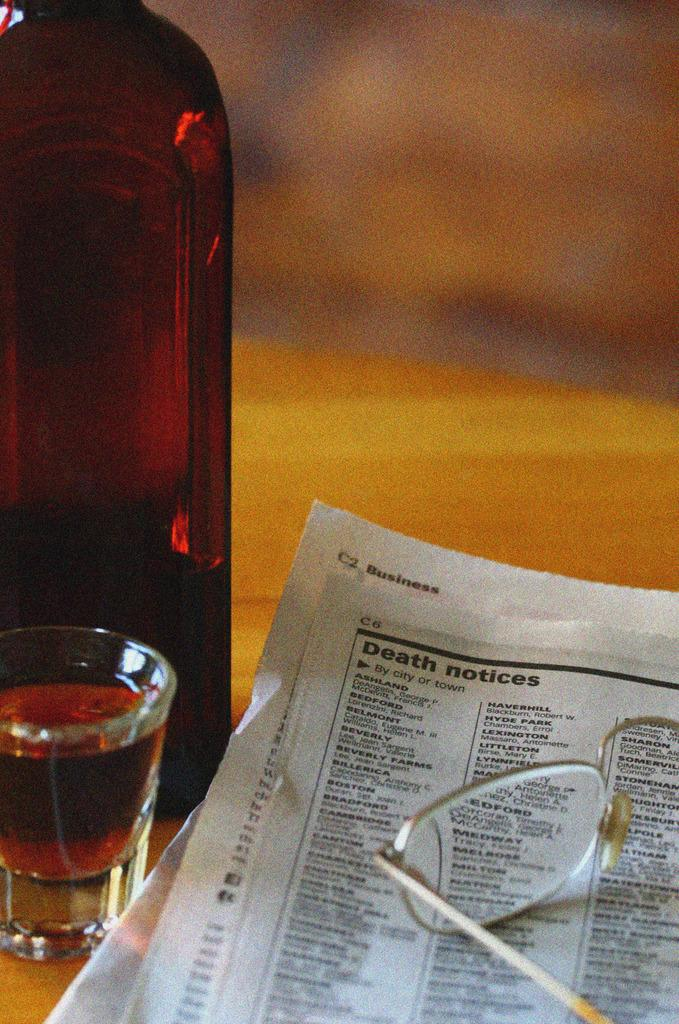<image>
Give a short and clear explanation of the subsequent image. A drink on a table next to a news paper open to the death notices. 